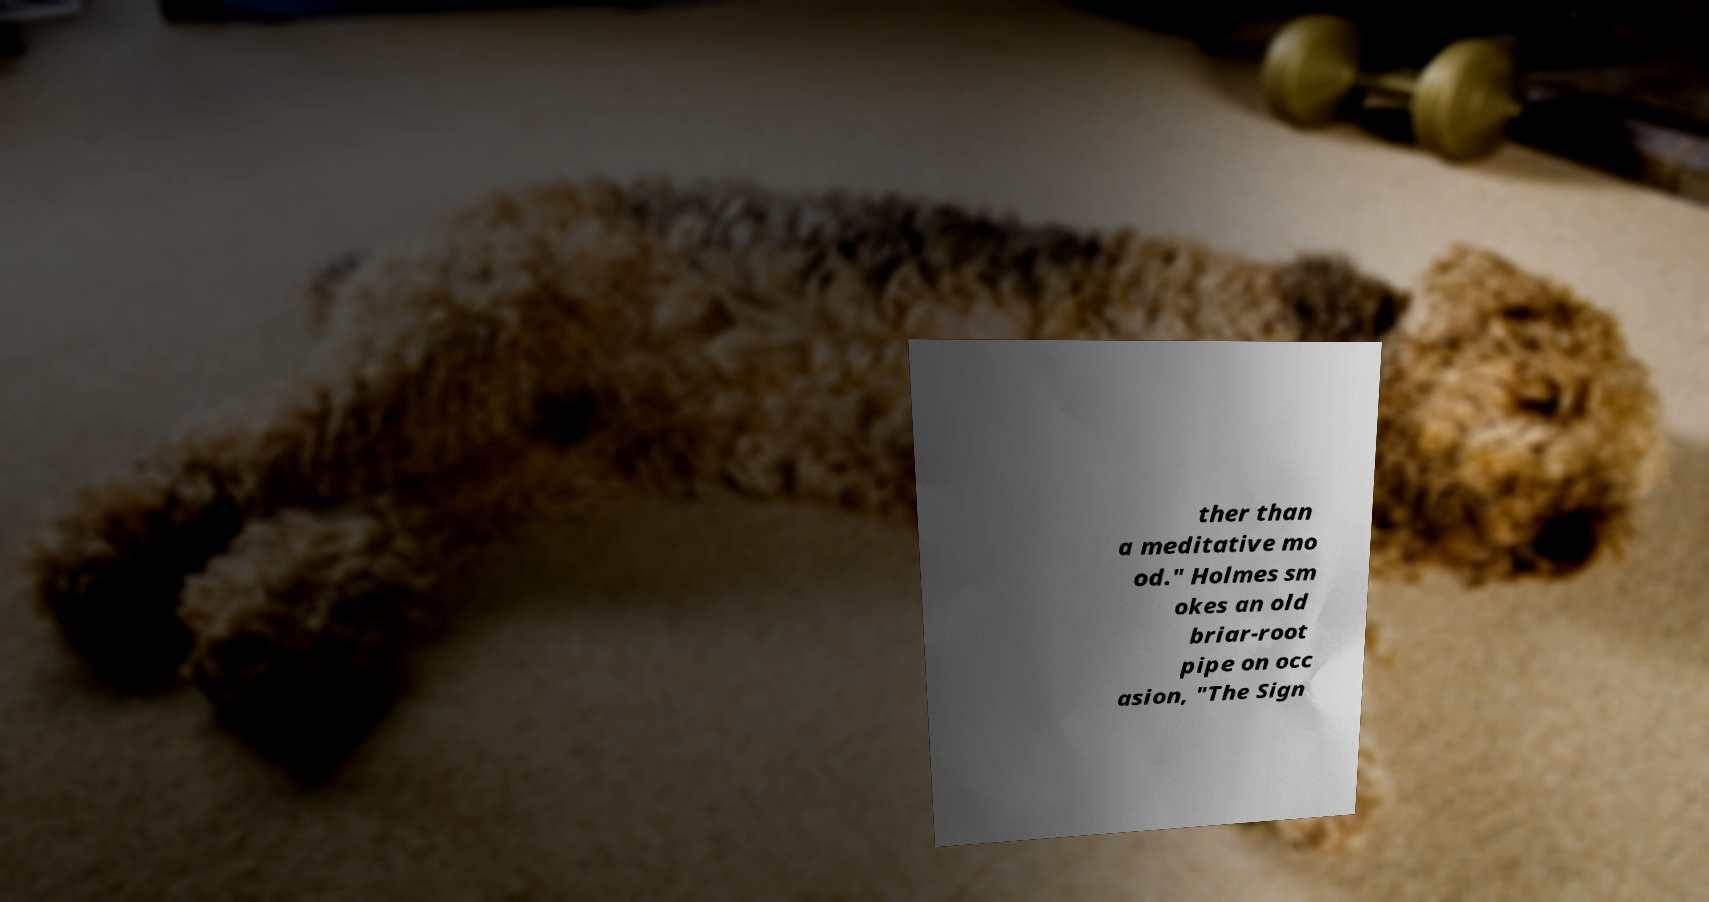What messages or text are displayed in this image? I need them in a readable, typed format. ther than a meditative mo od." Holmes sm okes an old briar-root pipe on occ asion, "The Sign 